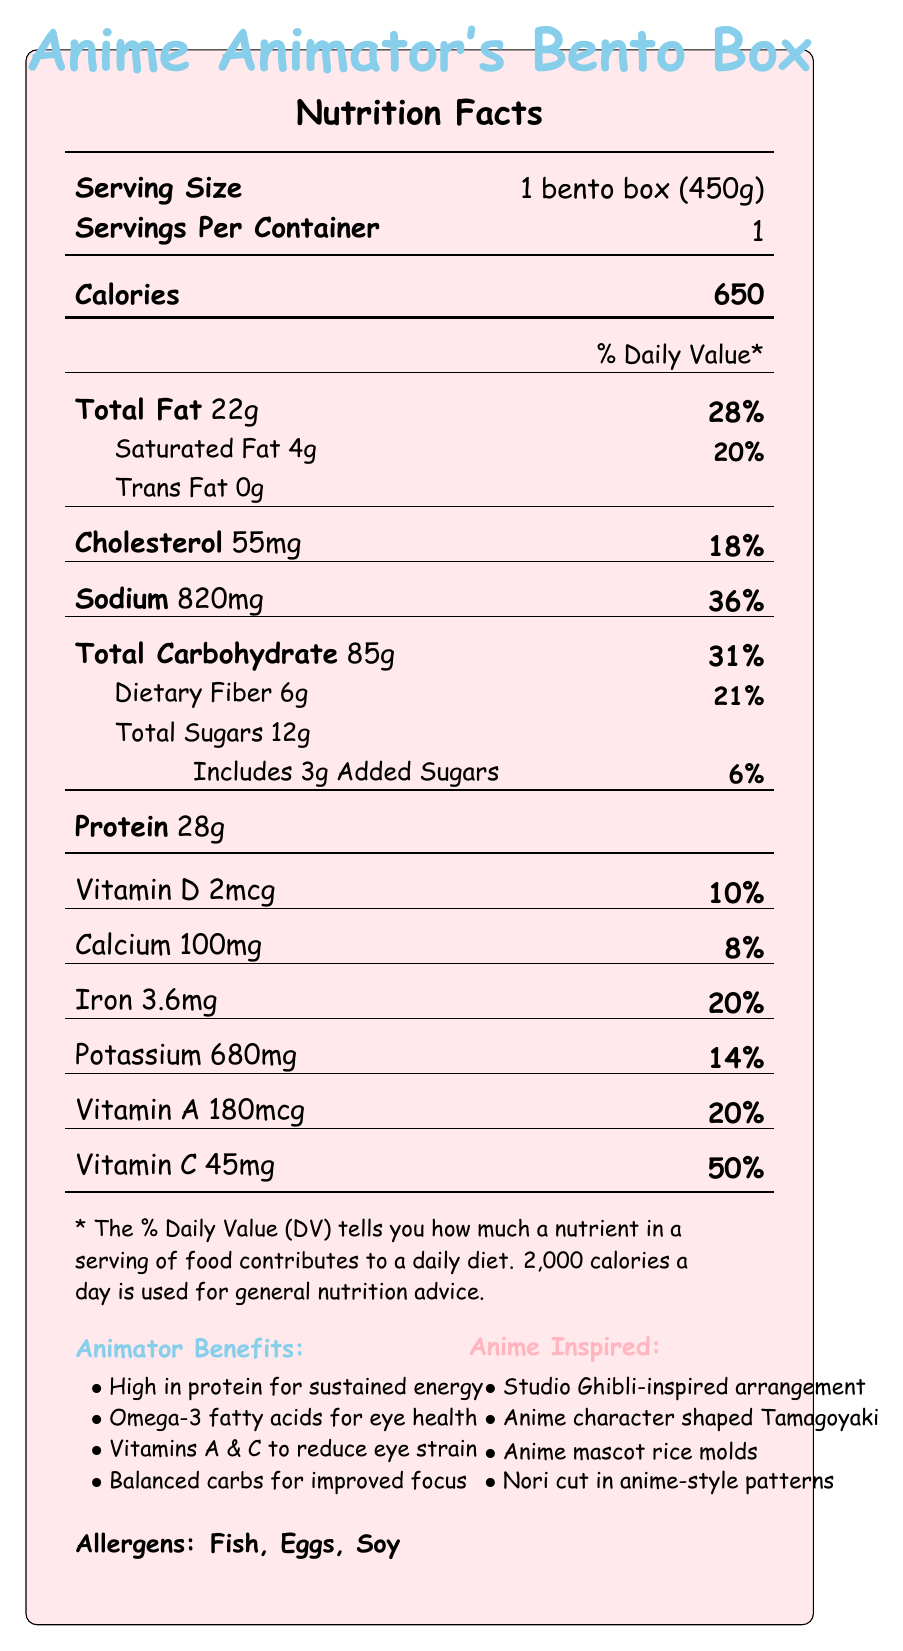what is the serving size of the bento box? The serving size is clearly specified as "1 bento box (450g)" under the "Serving Size" section of the document.
Answer: 1 bento box (450g) how many calories are in a serving of the bento box? The calorie amount per serving is listed as "650" under the "Calories" section.
Answer: 650 what percent of the Daily Value is provided by the total fat in the bento box? The total fat amount is 22g, and its % Daily Value is indicated as "28%".
Answer: 28% how much dietary fiber does the bento box contain? The document specifies "Dietary Fiber 6g" under the "Total Carbohydrate" section.
Answer: 6g which ingredient in the bento box has the highest quantity of added sugars? Based on the ingredients list and common food knowledge, soy sauce most likely contains the added sugars, though the document does not break it down specifically by ingredient; rather, it lists total added sugars as "3g".
Answer: Soy sauce what benefits does the bento box provide for animators? A. High in protein B. Low in calories C. Rich in omega-3 D. Contains caffeine The document lists several benefits including "High in protein for sustained energy" and "Contains omega-3 fatty acids from salmon to support eye health," but not specifically mentioning low calories or caffeine.
Answer: A, C which of the following nutrients contributes the lowest percentage of the daily value? 1. Vitamin A 2. Calcium 3. Iron 4. Vitamin D Calcium contributes "8%" of the Daily Value, which is lower than the contributions from Vitamin A (20%), Iron (20%), and Vitamin D (10%).
Answer: 2. Calcium does the bento box include any soy-based ingredients? The document lists "Soy sauce" as an ingredient and "Soy" as an allergen.
Answer: Yes which elements in the bento box design are inspired by anime? The document mentions various anime-inspired elements: "Colorful arrangement inspired by Studio Ghibli food scenes," "Tamagoyaki cut into anime character shapes," "Rice molded to resemble popular anime mascots," and "Nori cut into intricate anime-style patterns."
Answer: Colorful arrangement, Tamagoyaki shapes, Rice molds, Nori patterns summarize the main idea of this document. This summary captures all the essential information including nutritional values, anime-inspired design elements, animator benefits, and allergens mentioned in the document.
Answer: The document provides nutritional information for an anime-themed bento box tailored for digital animators, detailing its serving size, calorie content, and various nutrients. It also highlights anime-inspired design elements and specific benefits for animators, along with identifying allergens. what is the source of omega-3 fatty acids in the bento box? The document states that omega-3 fatty acids come from salmon, providing a specific benefit for eye health.
Answer: Grilled salmon how much sodium does the bento box contain and what is its daily value percentage? The document lists sodium content as "820mg" and its % Daily Value as "36%".
Answer: 820mg, 36% calculate the percentage contribution of protein to the total calorie count, if each gram of protein provides 4 calories. The bento box contains 28g of protein. Each gram of protein provides 4 calories (28g * 4 = 112 calories from protein). Thus, (112 / 650) * 100 ≈ 17.2%.
Answer: ≈17.2% are there any added sugars in the bento box? The document specifies "Includes 3g Added Sugars."
Answer: Yes what are the allergens listed in the bento box? The document clearly lists "Fish, Eggs, Soy" under the "Allergens" section.
Answer: Fish, Eggs, Soy what is the amount of potassium provided and its percentage of the daily value? The potassium content is specified as "680mg" and its % Daily Value as "14%".
Answer: 680mg, 14% what type of oil is used in the bento box? The document lists "Sesame oil" as one of the ingredients.
Answer: Sesame oil who is the target audience for this bento box? The document specifically refers to benefits for digital animators and includes anime-inspired elements.
Answer: Digital animators what inspired the colorful food arrangement in this bento box? The document mentions that the bento box has a "Colorful arrangement inspired by Studio Ghibli food scenes".
Answer: Studio Ghibli food scenes what does "% Daily Value (DV) tells you" mean? This information is provided as a footnote explaining the meaning of % Daily Value.
Answer: How much a nutrient in a serving of food contributes to a daily diet. how much omega-3 fatty acids are present in the bento box? The document mentions omega-3 fatty acids but does not provide a specific quantity, only stating that they come from grilled salmon.
Answer: Not enough information 